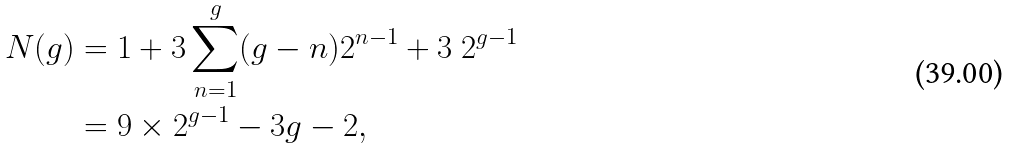<formula> <loc_0><loc_0><loc_500><loc_500>N ( g ) & = 1 + 3 \sum _ { n = 1 } ^ { g } ( g - n ) 2 ^ { n - 1 } + 3 \ 2 ^ { g - 1 } \\ & = 9 \times 2 ^ { g - 1 } - 3 g - 2 ,</formula> 